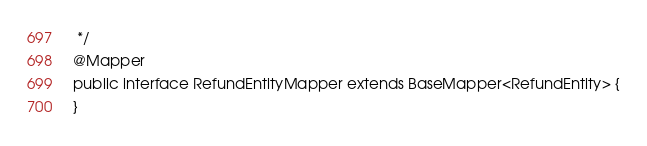<code> <loc_0><loc_0><loc_500><loc_500><_Java_> */
@Mapper
public interface RefundEntityMapper extends BaseMapper<RefundEntity> {
}
</code> 